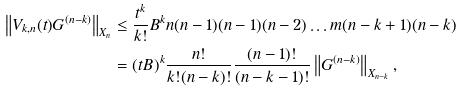<formula> <loc_0><loc_0><loc_500><loc_500>\left \| V _ { k , n } ( t ) G ^ { ( n - k ) } \right \| _ { X _ { n } } & \leq \frac { t ^ { k } } { k ! } B ^ { k } n ( n - 1 ) ( n - 1 ) ( n - 2 ) \dots m ( n - k + 1 ) ( n - k ) \\ & = ( t B ) ^ { k } \frac { n ! } { k ! ( n - k ) ! } \frac { ( n - 1 ) ! } { ( n - k - 1 ) ! } \left \| G ^ { ( n - k ) } \right \| _ { X _ { n - k } } ,</formula> 